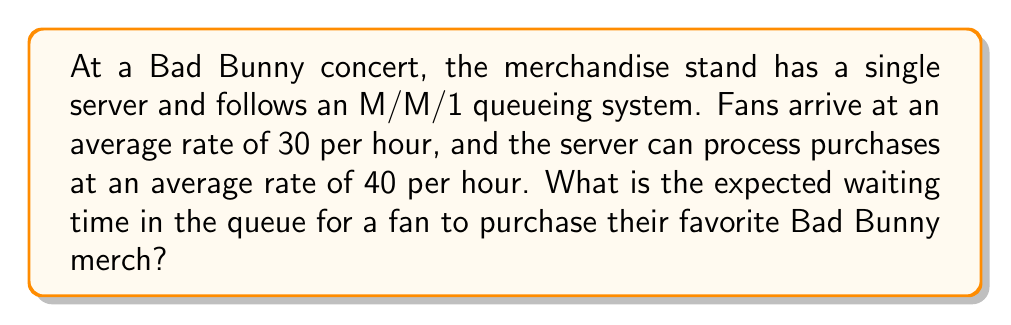Teach me how to tackle this problem. To solve this problem, we'll use the M/M/1 queueing theory model:

1. Define the variables:
   $\lambda$ = arrival rate = 30 fans/hour
   $\mu$ = service rate = 40 fans/hour

2. Calculate the utilization factor $\rho$:
   $$\rho = \frac{\lambda}{\mu} = \frac{30}{40} = 0.75$$

3. The expected waiting time in the queue (Wq) for an M/M/1 system is given by:
   $$W_q = \frac{\rho}{\mu - \lambda}$$

4. Substitute the values:
   $$W_q = \frac{0.75}{40 - 30} = \frac{0.75}{10} = 0.075\text{ hours}$$

5. Convert the result to minutes:
   $$0.075 \text{ hours} \times 60 \text{ minutes/hour} = 4.5 \text{ minutes}$$

Therefore, the expected waiting time in the queue for a fan to purchase Bad Bunny merch is 4.5 minutes.
Answer: 4.5 minutes 